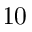Convert formula to latex. <formula><loc_0><loc_0><loc_500><loc_500>1 0</formula> 